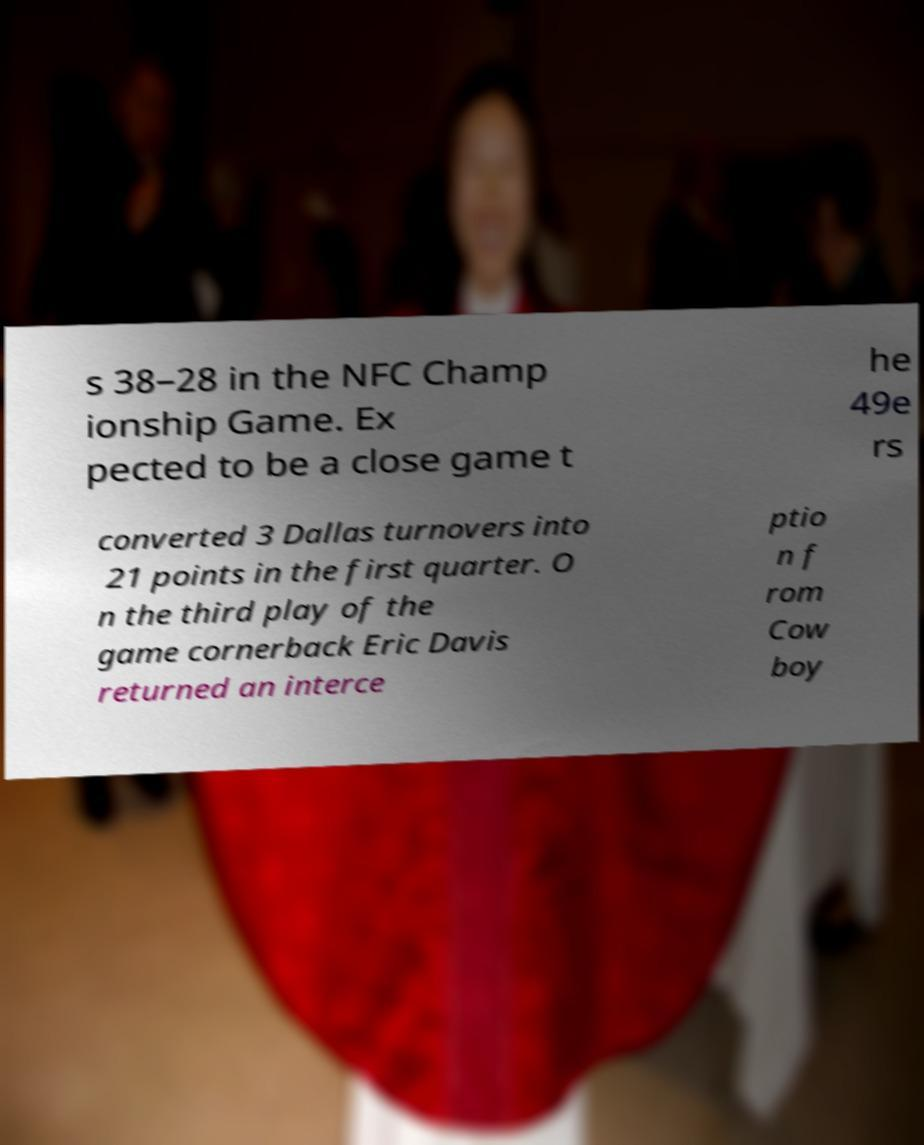Please identify and transcribe the text found in this image. s 38–28 in the NFC Champ ionship Game. Ex pected to be a close game t he 49e rs converted 3 Dallas turnovers into 21 points in the first quarter. O n the third play of the game cornerback Eric Davis returned an interce ptio n f rom Cow boy 